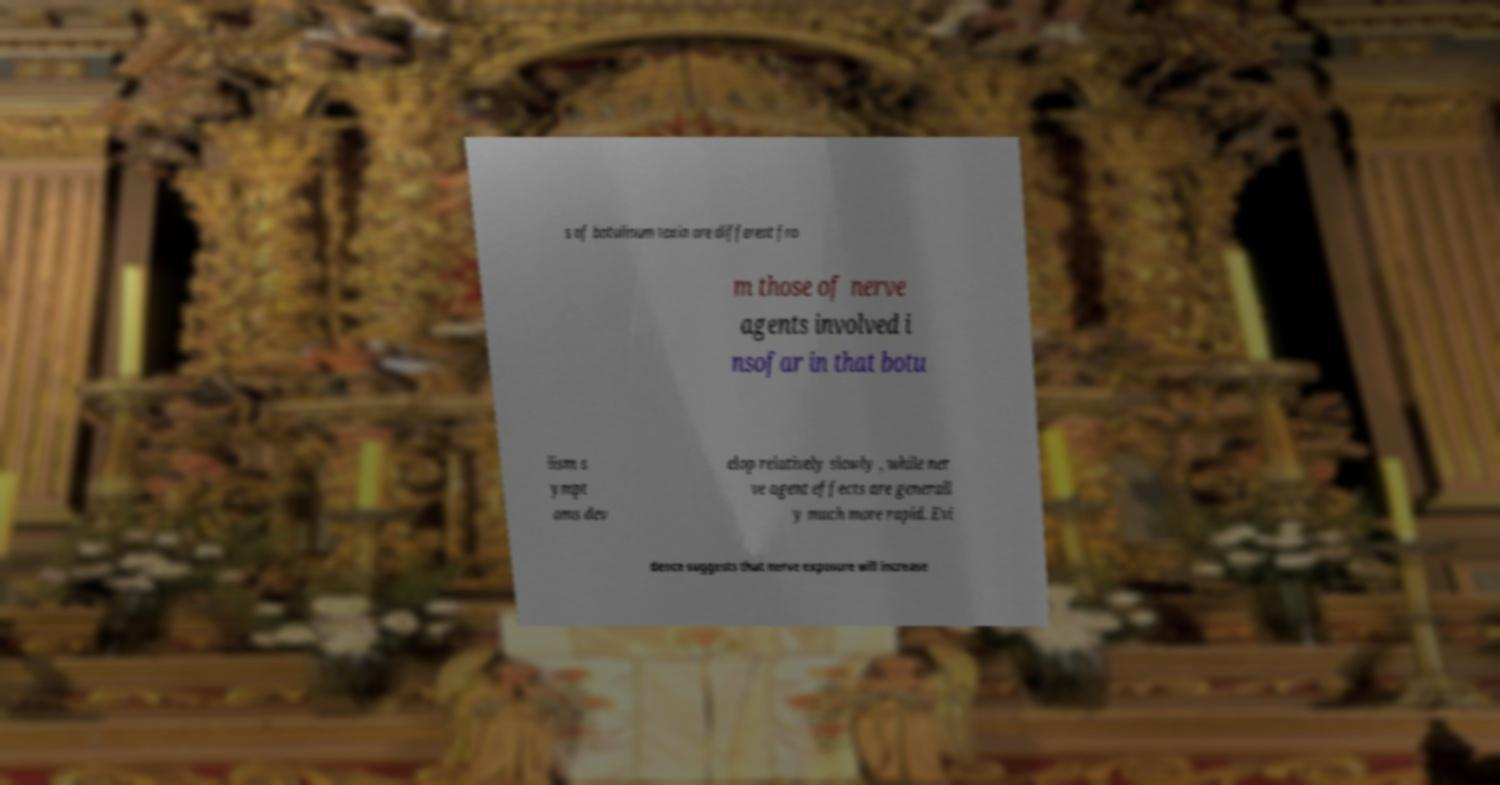Can you read and provide the text displayed in the image?This photo seems to have some interesting text. Can you extract and type it out for me? s of botulinum toxin are different fro m those of nerve agents involved i nsofar in that botu lism s ympt oms dev elop relatively slowly , while ner ve agent effects are generall y much more rapid. Evi dence suggests that nerve exposure will increase 